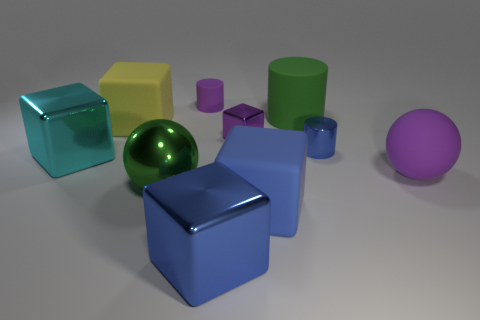Are there any tiny purple cylinders made of the same material as the purple sphere?
Give a very brief answer. Yes. What number of cubes are either tiny yellow metal objects or large green metal things?
Provide a succinct answer. 0. Is there a big green sphere in front of the purple matte thing in front of the small purple matte object?
Your answer should be very brief. Yes. Are there fewer large yellow matte cubes than purple objects?
Give a very brief answer. Yes. How many large purple matte things have the same shape as the tiny matte object?
Offer a terse response. 0. How many cyan things are shiny objects or big things?
Offer a very short reply. 1. What is the size of the blue matte cube to the right of the cylinder that is behind the big green matte cylinder?
Your answer should be compact. Large. What material is the other big object that is the same shape as the large purple matte object?
Ensure brevity in your answer.  Metal. How many blue metallic objects have the same size as the purple rubber cylinder?
Provide a succinct answer. 1. Does the cyan object have the same size as the green cylinder?
Give a very brief answer. Yes. 